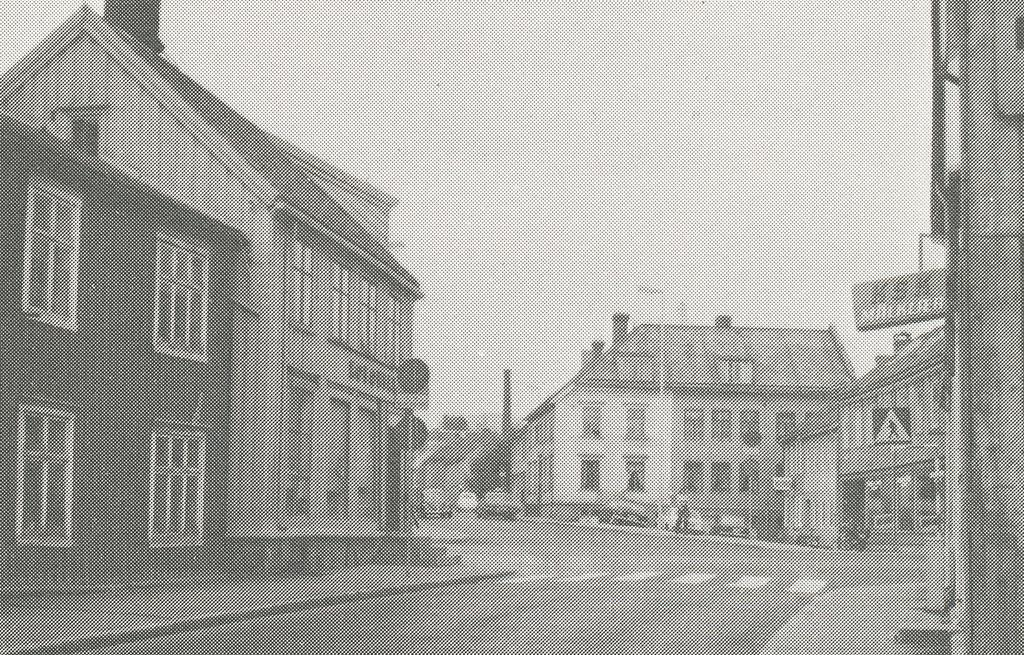<image>
Offer a succinct explanation of the picture presented. A sign on a building has the letters KSK on it. 